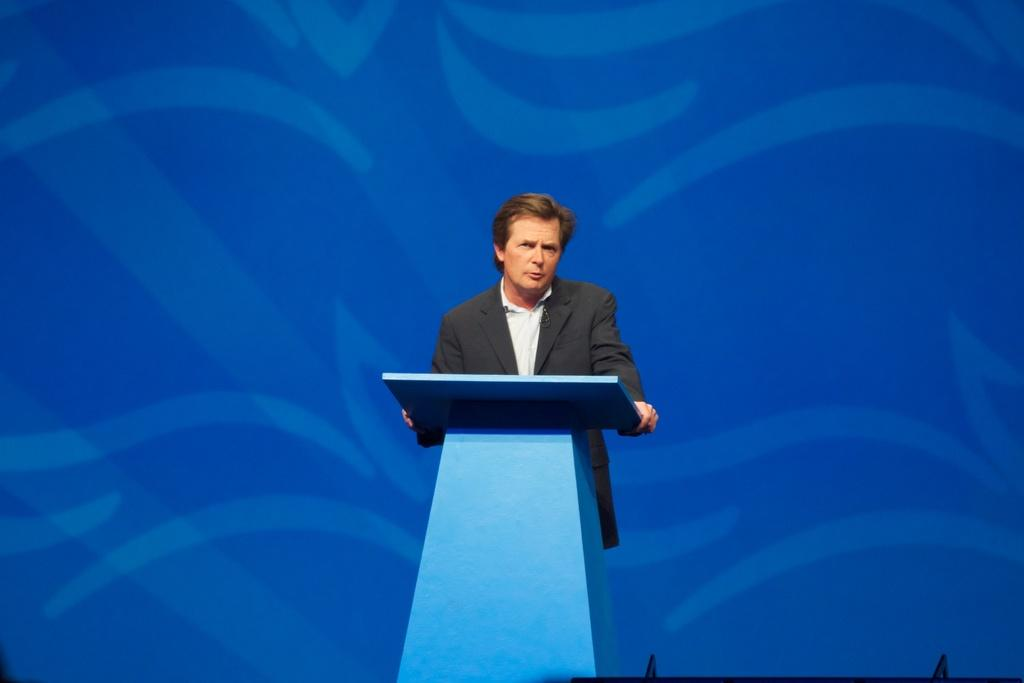What is the main subject of the image? The main subject of the image is a person standing on a dais. What can be seen behind the person? There is a wall behind the person. What type of question is being asked by the person on the dais in the image? There is no indication in the image that the person is asking a question, so it cannot be determined from the picture. 